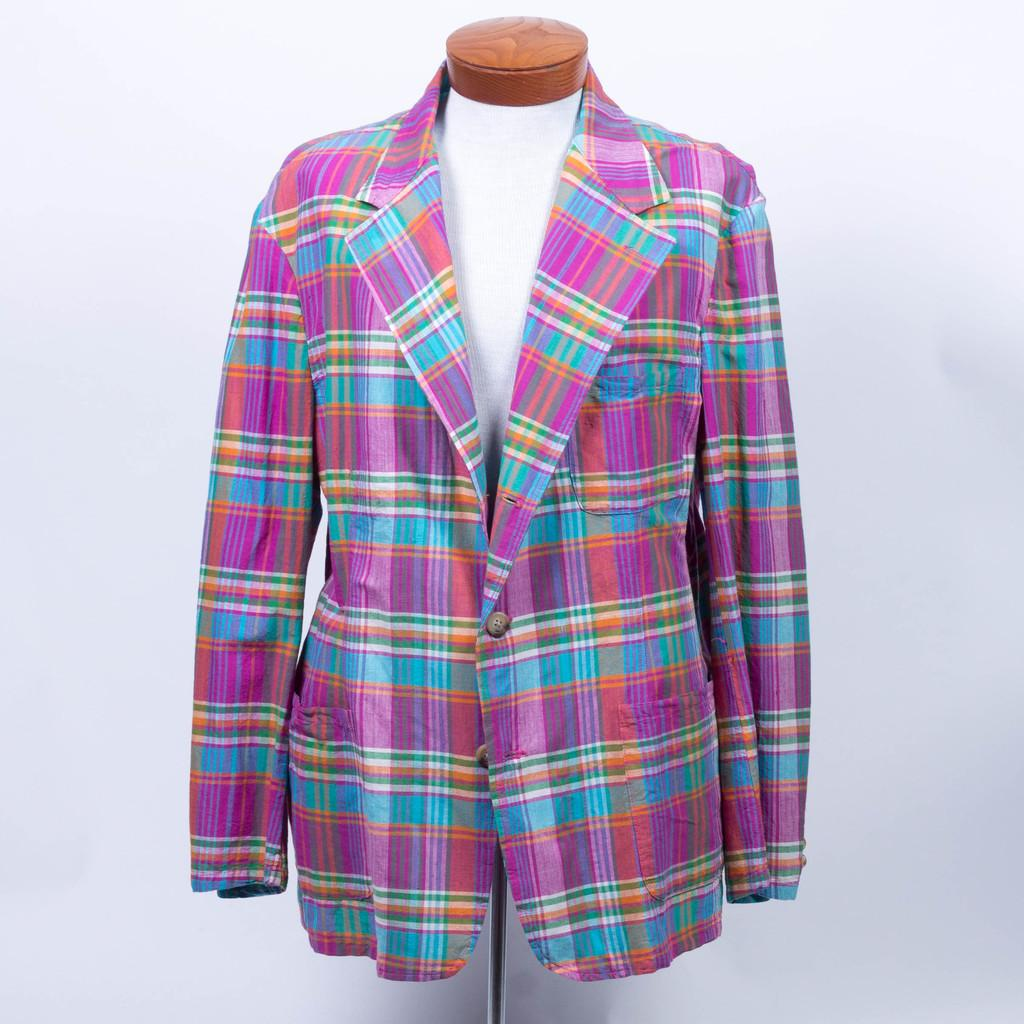What is the main subject of the image? The main subject of the image is a mannequin. What is the mannequin wearing in the image? The mannequin is wearing a coat in the image. How many tickets does the mannequin have in its hand in the image? There is no mention of tickets or hands in the image, as it features a mannequin wearing a coat. 